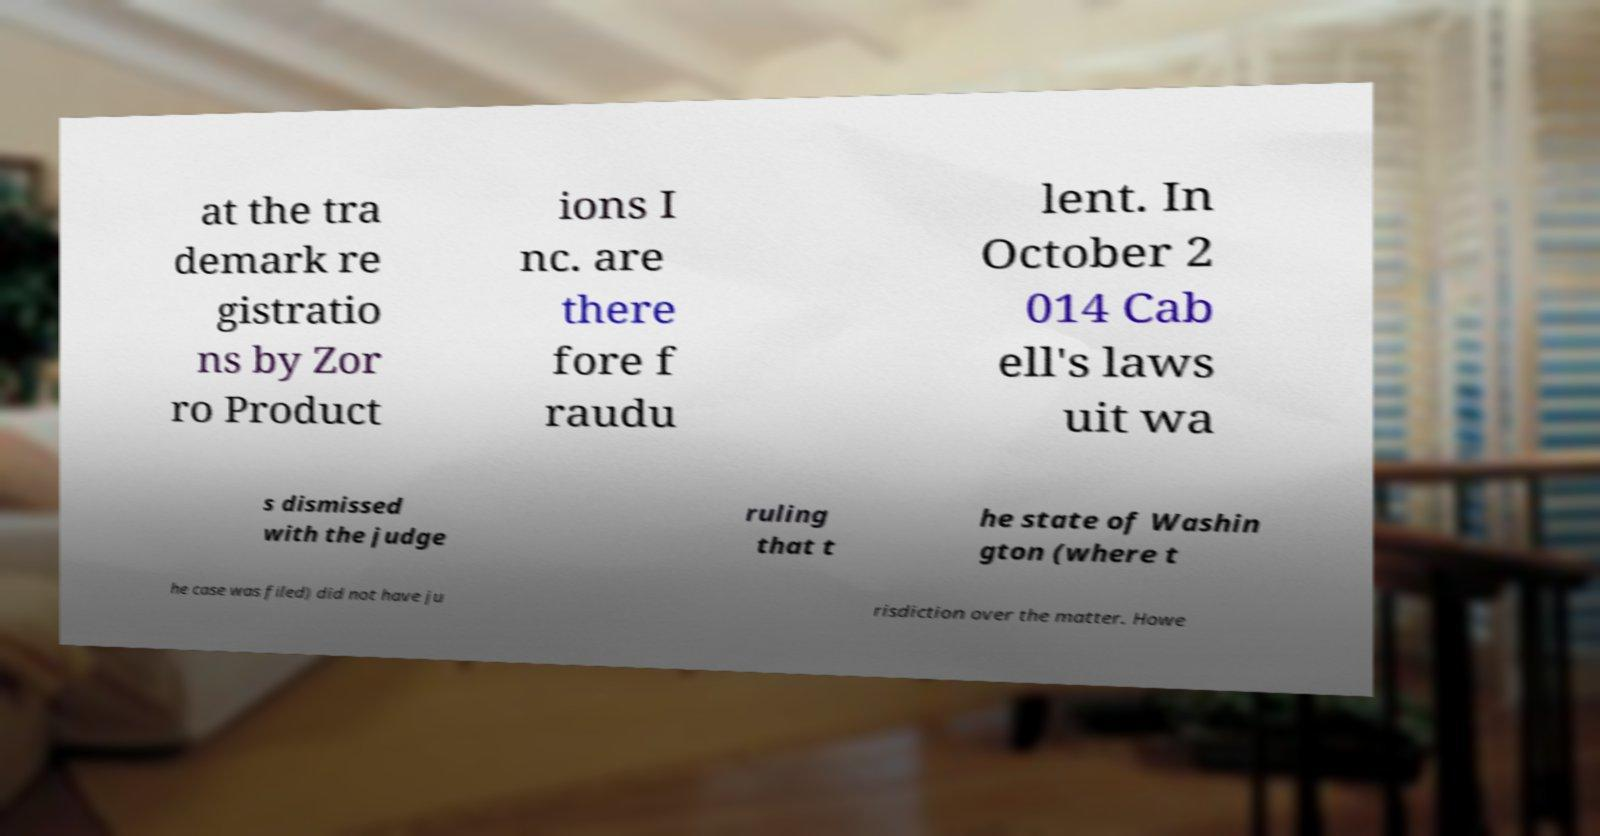For documentation purposes, I need the text within this image transcribed. Could you provide that? at the tra demark re gistratio ns by Zor ro Product ions I nc. are there fore f raudu lent. In October 2 014 Cab ell's laws uit wa s dismissed with the judge ruling that t he state of Washin gton (where t he case was filed) did not have ju risdiction over the matter. Howe 